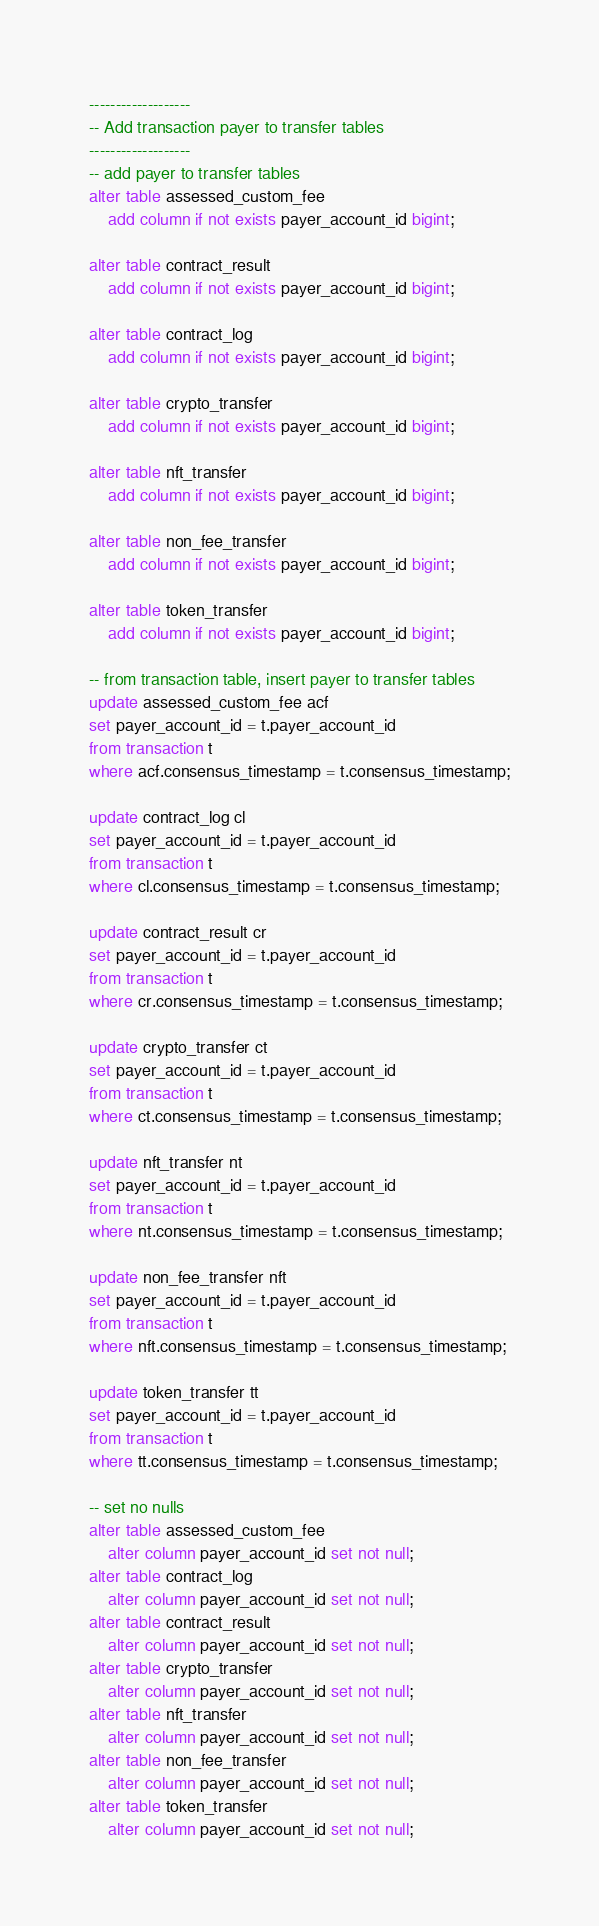<code> <loc_0><loc_0><loc_500><loc_500><_SQL_>-------------------
-- Add transaction payer to transfer tables
-------------------
-- add payer to transfer tables
alter table assessed_custom_fee
    add column if not exists payer_account_id bigint;

alter table contract_result
    add column if not exists payer_account_id bigint;

alter table contract_log
    add column if not exists payer_account_id bigint;

alter table crypto_transfer
    add column if not exists payer_account_id bigint;

alter table nft_transfer
    add column if not exists payer_account_id bigint;

alter table non_fee_transfer
    add column if not exists payer_account_id bigint;

alter table token_transfer
    add column if not exists payer_account_id bigint;

-- from transaction table, insert payer to transfer tables
update assessed_custom_fee acf
set payer_account_id = t.payer_account_id
from transaction t
where acf.consensus_timestamp = t.consensus_timestamp;

update contract_log cl
set payer_account_id = t.payer_account_id
from transaction t
where cl.consensus_timestamp = t.consensus_timestamp;

update contract_result cr
set payer_account_id = t.payer_account_id
from transaction t
where cr.consensus_timestamp = t.consensus_timestamp;

update crypto_transfer ct
set payer_account_id = t.payer_account_id
from transaction t
where ct.consensus_timestamp = t.consensus_timestamp;

update nft_transfer nt
set payer_account_id = t.payer_account_id
from transaction t
where nt.consensus_timestamp = t.consensus_timestamp;

update non_fee_transfer nft
set payer_account_id = t.payer_account_id
from transaction t
where nft.consensus_timestamp = t.consensus_timestamp;

update token_transfer tt
set payer_account_id = t.payer_account_id
from transaction t
where tt.consensus_timestamp = t.consensus_timestamp;

-- set no nulls
alter table assessed_custom_fee
    alter column payer_account_id set not null;
alter table contract_log
    alter column payer_account_id set not null;
alter table contract_result
    alter column payer_account_id set not null;
alter table crypto_transfer
    alter column payer_account_id set not null;
alter table nft_transfer
    alter column payer_account_id set not null;
alter table non_fee_transfer
    alter column payer_account_id set not null;
alter table token_transfer
    alter column payer_account_id set not null;
</code> 